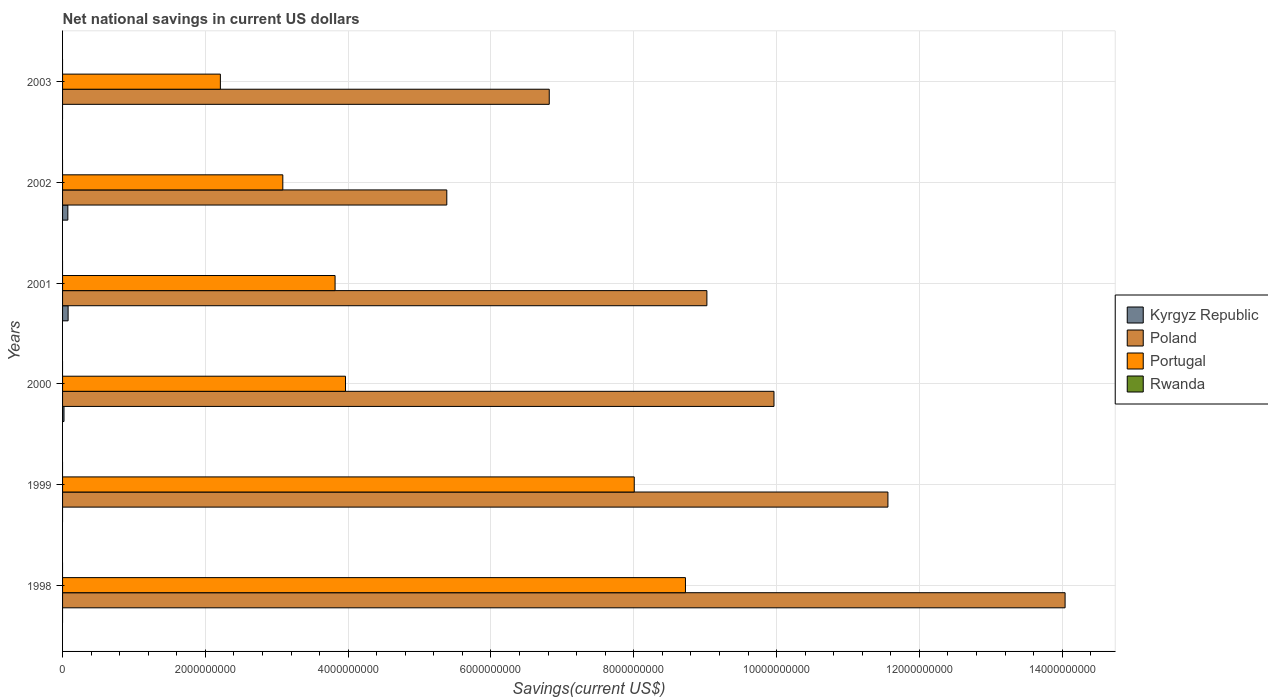How many different coloured bars are there?
Keep it short and to the point. 3. How many groups of bars are there?
Give a very brief answer. 6. Are the number of bars per tick equal to the number of legend labels?
Keep it short and to the point. No. Are the number of bars on each tick of the Y-axis equal?
Give a very brief answer. No. In how many cases, is the number of bars for a given year not equal to the number of legend labels?
Give a very brief answer. 6. What is the net national savings in Kyrgyz Republic in 2000?
Offer a terse response. 2.02e+07. Across all years, what is the maximum net national savings in Portugal?
Your answer should be very brief. 8.72e+09. In which year was the net national savings in Portugal maximum?
Offer a terse response. 1998. What is the total net national savings in Portugal in the graph?
Your answer should be compact. 2.98e+1. What is the difference between the net national savings in Poland in 1998 and that in 2001?
Give a very brief answer. 5.02e+09. What is the difference between the net national savings in Portugal in 2000 and the net national savings in Kyrgyz Republic in 2002?
Offer a very short reply. 3.89e+09. What is the average net national savings in Portugal per year?
Ensure brevity in your answer.  4.97e+09. In the year 2002, what is the difference between the net national savings in Kyrgyz Republic and net national savings in Portugal?
Provide a short and direct response. -3.01e+09. In how many years, is the net national savings in Poland greater than 10800000000 US$?
Offer a very short reply. 2. What is the ratio of the net national savings in Portugal in 1998 to that in 2001?
Your answer should be compact. 2.29. What is the difference between the highest and the second highest net national savings in Poland?
Keep it short and to the point. 2.48e+09. What is the difference between the highest and the lowest net national savings in Kyrgyz Republic?
Your answer should be very brief. 7.77e+07. Is it the case that in every year, the sum of the net national savings in Portugal and net national savings in Rwanda is greater than the net national savings in Poland?
Your answer should be very brief. No. How many bars are there?
Your answer should be very brief. 15. Are all the bars in the graph horizontal?
Provide a succinct answer. Yes. What is the difference between two consecutive major ticks on the X-axis?
Your response must be concise. 2.00e+09. What is the title of the graph?
Your response must be concise. Net national savings in current US dollars. What is the label or title of the X-axis?
Ensure brevity in your answer.  Savings(current US$). What is the Savings(current US$) of Kyrgyz Republic in 1998?
Ensure brevity in your answer.  0. What is the Savings(current US$) of Poland in 1998?
Offer a terse response. 1.40e+1. What is the Savings(current US$) in Portugal in 1998?
Offer a terse response. 8.72e+09. What is the Savings(current US$) in Rwanda in 1998?
Give a very brief answer. 0. What is the Savings(current US$) of Poland in 1999?
Offer a terse response. 1.16e+1. What is the Savings(current US$) in Portugal in 1999?
Your answer should be compact. 8.01e+09. What is the Savings(current US$) in Kyrgyz Republic in 2000?
Your answer should be very brief. 2.02e+07. What is the Savings(current US$) in Poland in 2000?
Offer a very short reply. 9.96e+09. What is the Savings(current US$) in Portugal in 2000?
Provide a short and direct response. 3.96e+09. What is the Savings(current US$) in Rwanda in 2000?
Your answer should be compact. 0. What is the Savings(current US$) in Kyrgyz Republic in 2001?
Your answer should be compact. 7.77e+07. What is the Savings(current US$) of Poland in 2001?
Make the answer very short. 9.02e+09. What is the Savings(current US$) in Portugal in 2001?
Keep it short and to the point. 3.82e+09. What is the Savings(current US$) of Kyrgyz Republic in 2002?
Keep it short and to the point. 7.40e+07. What is the Savings(current US$) of Poland in 2002?
Offer a very short reply. 5.38e+09. What is the Savings(current US$) in Portugal in 2002?
Ensure brevity in your answer.  3.08e+09. What is the Savings(current US$) of Kyrgyz Republic in 2003?
Ensure brevity in your answer.  0. What is the Savings(current US$) in Poland in 2003?
Your response must be concise. 6.82e+09. What is the Savings(current US$) in Portugal in 2003?
Offer a terse response. 2.21e+09. Across all years, what is the maximum Savings(current US$) of Kyrgyz Republic?
Give a very brief answer. 7.77e+07. Across all years, what is the maximum Savings(current US$) of Poland?
Give a very brief answer. 1.40e+1. Across all years, what is the maximum Savings(current US$) in Portugal?
Give a very brief answer. 8.72e+09. Across all years, what is the minimum Savings(current US$) in Kyrgyz Republic?
Offer a very short reply. 0. Across all years, what is the minimum Savings(current US$) in Poland?
Provide a short and direct response. 5.38e+09. Across all years, what is the minimum Savings(current US$) of Portugal?
Offer a very short reply. 2.21e+09. What is the total Savings(current US$) in Kyrgyz Republic in the graph?
Provide a succinct answer. 1.72e+08. What is the total Savings(current US$) in Poland in the graph?
Give a very brief answer. 5.68e+1. What is the total Savings(current US$) of Portugal in the graph?
Ensure brevity in your answer.  2.98e+1. What is the total Savings(current US$) in Rwanda in the graph?
Provide a short and direct response. 0. What is the difference between the Savings(current US$) of Poland in 1998 and that in 1999?
Ensure brevity in your answer.  2.48e+09. What is the difference between the Savings(current US$) in Portugal in 1998 and that in 1999?
Your response must be concise. 7.17e+08. What is the difference between the Savings(current US$) in Poland in 1998 and that in 2000?
Ensure brevity in your answer.  4.08e+09. What is the difference between the Savings(current US$) in Portugal in 1998 and that in 2000?
Offer a terse response. 4.76e+09. What is the difference between the Savings(current US$) in Poland in 1998 and that in 2001?
Provide a succinct answer. 5.02e+09. What is the difference between the Savings(current US$) of Portugal in 1998 and that in 2001?
Offer a terse response. 4.91e+09. What is the difference between the Savings(current US$) of Poland in 1998 and that in 2002?
Your answer should be very brief. 8.66e+09. What is the difference between the Savings(current US$) in Portugal in 1998 and that in 2002?
Keep it short and to the point. 5.64e+09. What is the difference between the Savings(current US$) in Poland in 1998 and that in 2003?
Keep it short and to the point. 7.22e+09. What is the difference between the Savings(current US$) of Portugal in 1998 and that in 2003?
Your answer should be very brief. 6.51e+09. What is the difference between the Savings(current US$) of Poland in 1999 and that in 2000?
Provide a succinct answer. 1.60e+09. What is the difference between the Savings(current US$) in Portugal in 1999 and that in 2000?
Give a very brief answer. 4.04e+09. What is the difference between the Savings(current US$) in Poland in 1999 and that in 2001?
Offer a very short reply. 2.54e+09. What is the difference between the Savings(current US$) in Portugal in 1999 and that in 2001?
Give a very brief answer. 4.19e+09. What is the difference between the Savings(current US$) in Poland in 1999 and that in 2002?
Offer a terse response. 6.18e+09. What is the difference between the Savings(current US$) of Portugal in 1999 and that in 2002?
Provide a short and direct response. 4.92e+09. What is the difference between the Savings(current US$) in Poland in 1999 and that in 2003?
Give a very brief answer. 4.74e+09. What is the difference between the Savings(current US$) in Portugal in 1999 and that in 2003?
Your answer should be very brief. 5.80e+09. What is the difference between the Savings(current US$) in Kyrgyz Republic in 2000 and that in 2001?
Offer a very short reply. -5.76e+07. What is the difference between the Savings(current US$) in Poland in 2000 and that in 2001?
Provide a short and direct response. 9.39e+08. What is the difference between the Savings(current US$) of Portugal in 2000 and that in 2001?
Make the answer very short. 1.46e+08. What is the difference between the Savings(current US$) of Kyrgyz Republic in 2000 and that in 2002?
Make the answer very short. -5.38e+07. What is the difference between the Savings(current US$) of Poland in 2000 and that in 2002?
Provide a short and direct response. 4.58e+09. What is the difference between the Savings(current US$) in Portugal in 2000 and that in 2002?
Your answer should be compact. 8.78e+08. What is the difference between the Savings(current US$) of Poland in 2000 and that in 2003?
Your answer should be very brief. 3.15e+09. What is the difference between the Savings(current US$) of Portugal in 2000 and that in 2003?
Provide a succinct answer. 1.75e+09. What is the difference between the Savings(current US$) in Kyrgyz Republic in 2001 and that in 2002?
Provide a succinct answer. 3.75e+06. What is the difference between the Savings(current US$) in Poland in 2001 and that in 2002?
Keep it short and to the point. 3.64e+09. What is the difference between the Savings(current US$) of Portugal in 2001 and that in 2002?
Your answer should be compact. 7.32e+08. What is the difference between the Savings(current US$) of Poland in 2001 and that in 2003?
Offer a very short reply. 2.21e+09. What is the difference between the Savings(current US$) in Portugal in 2001 and that in 2003?
Offer a terse response. 1.61e+09. What is the difference between the Savings(current US$) in Poland in 2002 and that in 2003?
Give a very brief answer. -1.43e+09. What is the difference between the Savings(current US$) of Portugal in 2002 and that in 2003?
Offer a terse response. 8.75e+08. What is the difference between the Savings(current US$) of Poland in 1998 and the Savings(current US$) of Portugal in 1999?
Make the answer very short. 6.03e+09. What is the difference between the Savings(current US$) in Poland in 1998 and the Savings(current US$) in Portugal in 2000?
Give a very brief answer. 1.01e+1. What is the difference between the Savings(current US$) of Poland in 1998 and the Savings(current US$) of Portugal in 2001?
Provide a short and direct response. 1.02e+1. What is the difference between the Savings(current US$) of Poland in 1998 and the Savings(current US$) of Portugal in 2002?
Your response must be concise. 1.10e+1. What is the difference between the Savings(current US$) in Poland in 1998 and the Savings(current US$) in Portugal in 2003?
Make the answer very short. 1.18e+1. What is the difference between the Savings(current US$) of Poland in 1999 and the Savings(current US$) of Portugal in 2000?
Keep it short and to the point. 7.60e+09. What is the difference between the Savings(current US$) in Poland in 1999 and the Savings(current US$) in Portugal in 2001?
Your response must be concise. 7.74e+09. What is the difference between the Savings(current US$) of Poland in 1999 and the Savings(current US$) of Portugal in 2002?
Make the answer very short. 8.47e+09. What is the difference between the Savings(current US$) of Poland in 1999 and the Savings(current US$) of Portugal in 2003?
Make the answer very short. 9.35e+09. What is the difference between the Savings(current US$) in Kyrgyz Republic in 2000 and the Savings(current US$) in Poland in 2001?
Offer a terse response. -9.00e+09. What is the difference between the Savings(current US$) of Kyrgyz Republic in 2000 and the Savings(current US$) of Portugal in 2001?
Provide a short and direct response. -3.80e+09. What is the difference between the Savings(current US$) in Poland in 2000 and the Savings(current US$) in Portugal in 2001?
Your answer should be very brief. 6.15e+09. What is the difference between the Savings(current US$) of Kyrgyz Republic in 2000 and the Savings(current US$) of Poland in 2002?
Offer a very short reply. -5.36e+09. What is the difference between the Savings(current US$) in Kyrgyz Republic in 2000 and the Savings(current US$) in Portugal in 2002?
Offer a very short reply. -3.06e+09. What is the difference between the Savings(current US$) of Poland in 2000 and the Savings(current US$) of Portugal in 2002?
Your answer should be compact. 6.88e+09. What is the difference between the Savings(current US$) of Kyrgyz Republic in 2000 and the Savings(current US$) of Poland in 2003?
Offer a terse response. -6.80e+09. What is the difference between the Savings(current US$) in Kyrgyz Republic in 2000 and the Savings(current US$) in Portugal in 2003?
Make the answer very short. -2.19e+09. What is the difference between the Savings(current US$) in Poland in 2000 and the Savings(current US$) in Portugal in 2003?
Your response must be concise. 7.75e+09. What is the difference between the Savings(current US$) in Kyrgyz Republic in 2001 and the Savings(current US$) in Poland in 2002?
Ensure brevity in your answer.  -5.30e+09. What is the difference between the Savings(current US$) in Kyrgyz Republic in 2001 and the Savings(current US$) in Portugal in 2002?
Provide a short and direct response. -3.01e+09. What is the difference between the Savings(current US$) in Poland in 2001 and the Savings(current US$) in Portugal in 2002?
Your response must be concise. 5.94e+09. What is the difference between the Savings(current US$) of Kyrgyz Republic in 2001 and the Savings(current US$) of Poland in 2003?
Provide a succinct answer. -6.74e+09. What is the difference between the Savings(current US$) of Kyrgyz Republic in 2001 and the Savings(current US$) of Portugal in 2003?
Make the answer very short. -2.13e+09. What is the difference between the Savings(current US$) in Poland in 2001 and the Savings(current US$) in Portugal in 2003?
Ensure brevity in your answer.  6.81e+09. What is the difference between the Savings(current US$) of Kyrgyz Republic in 2002 and the Savings(current US$) of Poland in 2003?
Give a very brief answer. -6.74e+09. What is the difference between the Savings(current US$) of Kyrgyz Republic in 2002 and the Savings(current US$) of Portugal in 2003?
Provide a short and direct response. -2.14e+09. What is the difference between the Savings(current US$) in Poland in 2002 and the Savings(current US$) in Portugal in 2003?
Offer a very short reply. 3.17e+09. What is the average Savings(current US$) in Kyrgyz Republic per year?
Keep it short and to the point. 2.86e+07. What is the average Savings(current US$) of Poland per year?
Provide a short and direct response. 9.46e+09. What is the average Savings(current US$) in Portugal per year?
Provide a short and direct response. 4.97e+09. In the year 1998, what is the difference between the Savings(current US$) in Poland and Savings(current US$) in Portugal?
Your response must be concise. 5.32e+09. In the year 1999, what is the difference between the Savings(current US$) in Poland and Savings(current US$) in Portugal?
Offer a very short reply. 3.55e+09. In the year 2000, what is the difference between the Savings(current US$) of Kyrgyz Republic and Savings(current US$) of Poland?
Offer a terse response. -9.94e+09. In the year 2000, what is the difference between the Savings(current US$) of Kyrgyz Republic and Savings(current US$) of Portugal?
Your response must be concise. -3.94e+09. In the year 2000, what is the difference between the Savings(current US$) in Poland and Savings(current US$) in Portugal?
Your answer should be compact. 6.00e+09. In the year 2001, what is the difference between the Savings(current US$) in Kyrgyz Republic and Savings(current US$) in Poland?
Make the answer very short. -8.95e+09. In the year 2001, what is the difference between the Savings(current US$) in Kyrgyz Republic and Savings(current US$) in Portugal?
Offer a very short reply. -3.74e+09. In the year 2001, what is the difference between the Savings(current US$) of Poland and Savings(current US$) of Portugal?
Provide a short and direct response. 5.21e+09. In the year 2002, what is the difference between the Savings(current US$) in Kyrgyz Republic and Savings(current US$) in Poland?
Your answer should be compact. -5.31e+09. In the year 2002, what is the difference between the Savings(current US$) in Kyrgyz Republic and Savings(current US$) in Portugal?
Give a very brief answer. -3.01e+09. In the year 2002, what is the difference between the Savings(current US$) in Poland and Savings(current US$) in Portugal?
Your response must be concise. 2.30e+09. In the year 2003, what is the difference between the Savings(current US$) in Poland and Savings(current US$) in Portugal?
Provide a short and direct response. 4.61e+09. What is the ratio of the Savings(current US$) of Poland in 1998 to that in 1999?
Your answer should be very brief. 1.21. What is the ratio of the Savings(current US$) of Portugal in 1998 to that in 1999?
Keep it short and to the point. 1.09. What is the ratio of the Savings(current US$) in Poland in 1998 to that in 2000?
Keep it short and to the point. 1.41. What is the ratio of the Savings(current US$) in Portugal in 1998 to that in 2000?
Keep it short and to the point. 2.2. What is the ratio of the Savings(current US$) of Poland in 1998 to that in 2001?
Ensure brevity in your answer.  1.56. What is the ratio of the Savings(current US$) of Portugal in 1998 to that in 2001?
Provide a succinct answer. 2.29. What is the ratio of the Savings(current US$) in Poland in 1998 to that in 2002?
Offer a terse response. 2.61. What is the ratio of the Savings(current US$) of Portugal in 1998 to that in 2002?
Keep it short and to the point. 2.83. What is the ratio of the Savings(current US$) of Poland in 1998 to that in 2003?
Give a very brief answer. 2.06. What is the ratio of the Savings(current US$) of Portugal in 1998 to that in 2003?
Offer a terse response. 3.95. What is the ratio of the Savings(current US$) in Poland in 1999 to that in 2000?
Make the answer very short. 1.16. What is the ratio of the Savings(current US$) in Portugal in 1999 to that in 2000?
Your response must be concise. 2.02. What is the ratio of the Savings(current US$) in Poland in 1999 to that in 2001?
Your answer should be very brief. 1.28. What is the ratio of the Savings(current US$) of Portugal in 1999 to that in 2001?
Provide a short and direct response. 2.1. What is the ratio of the Savings(current US$) in Poland in 1999 to that in 2002?
Offer a very short reply. 2.15. What is the ratio of the Savings(current US$) in Portugal in 1999 to that in 2002?
Provide a succinct answer. 2.6. What is the ratio of the Savings(current US$) in Poland in 1999 to that in 2003?
Provide a short and direct response. 1.7. What is the ratio of the Savings(current US$) in Portugal in 1999 to that in 2003?
Your response must be concise. 3.62. What is the ratio of the Savings(current US$) in Kyrgyz Republic in 2000 to that in 2001?
Your answer should be very brief. 0.26. What is the ratio of the Savings(current US$) in Poland in 2000 to that in 2001?
Offer a very short reply. 1.1. What is the ratio of the Savings(current US$) of Portugal in 2000 to that in 2001?
Give a very brief answer. 1.04. What is the ratio of the Savings(current US$) of Kyrgyz Republic in 2000 to that in 2002?
Offer a very short reply. 0.27. What is the ratio of the Savings(current US$) of Poland in 2000 to that in 2002?
Your response must be concise. 1.85. What is the ratio of the Savings(current US$) in Portugal in 2000 to that in 2002?
Provide a succinct answer. 1.28. What is the ratio of the Savings(current US$) in Poland in 2000 to that in 2003?
Make the answer very short. 1.46. What is the ratio of the Savings(current US$) in Portugal in 2000 to that in 2003?
Provide a short and direct response. 1.79. What is the ratio of the Savings(current US$) in Kyrgyz Republic in 2001 to that in 2002?
Make the answer very short. 1.05. What is the ratio of the Savings(current US$) in Poland in 2001 to that in 2002?
Your answer should be compact. 1.68. What is the ratio of the Savings(current US$) of Portugal in 2001 to that in 2002?
Provide a succinct answer. 1.24. What is the ratio of the Savings(current US$) in Poland in 2001 to that in 2003?
Provide a short and direct response. 1.32. What is the ratio of the Savings(current US$) of Portugal in 2001 to that in 2003?
Keep it short and to the point. 1.73. What is the ratio of the Savings(current US$) in Poland in 2002 to that in 2003?
Your answer should be very brief. 0.79. What is the ratio of the Savings(current US$) of Portugal in 2002 to that in 2003?
Make the answer very short. 1.4. What is the difference between the highest and the second highest Savings(current US$) of Kyrgyz Republic?
Provide a short and direct response. 3.75e+06. What is the difference between the highest and the second highest Savings(current US$) in Poland?
Your response must be concise. 2.48e+09. What is the difference between the highest and the second highest Savings(current US$) of Portugal?
Keep it short and to the point. 7.17e+08. What is the difference between the highest and the lowest Savings(current US$) in Kyrgyz Republic?
Provide a succinct answer. 7.77e+07. What is the difference between the highest and the lowest Savings(current US$) of Poland?
Your response must be concise. 8.66e+09. What is the difference between the highest and the lowest Savings(current US$) of Portugal?
Your answer should be compact. 6.51e+09. 